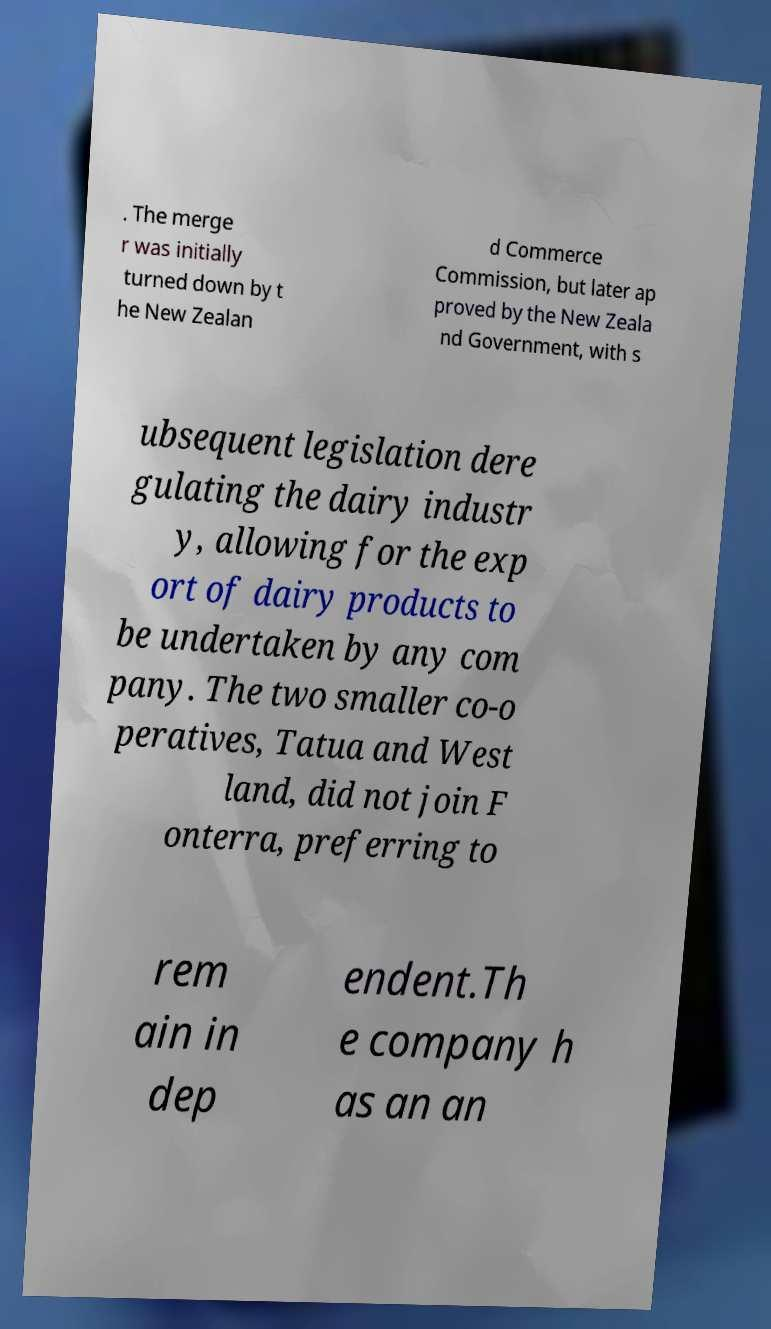Can you accurately transcribe the text from the provided image for me? . The merge r was initially turned down by t he New Zealan d Commerce Commission, but later ap proved by the New Zeala nd Government, with s ubsequent legislation dere gulating the dairy industr y, allowing for the exp ort of dairy products to be undertaken by any com pany. The two smaller co-o peratives, Tatua and West land, did not join F onterra, preferring to rem ain in dep endent.Th e company h as an an 